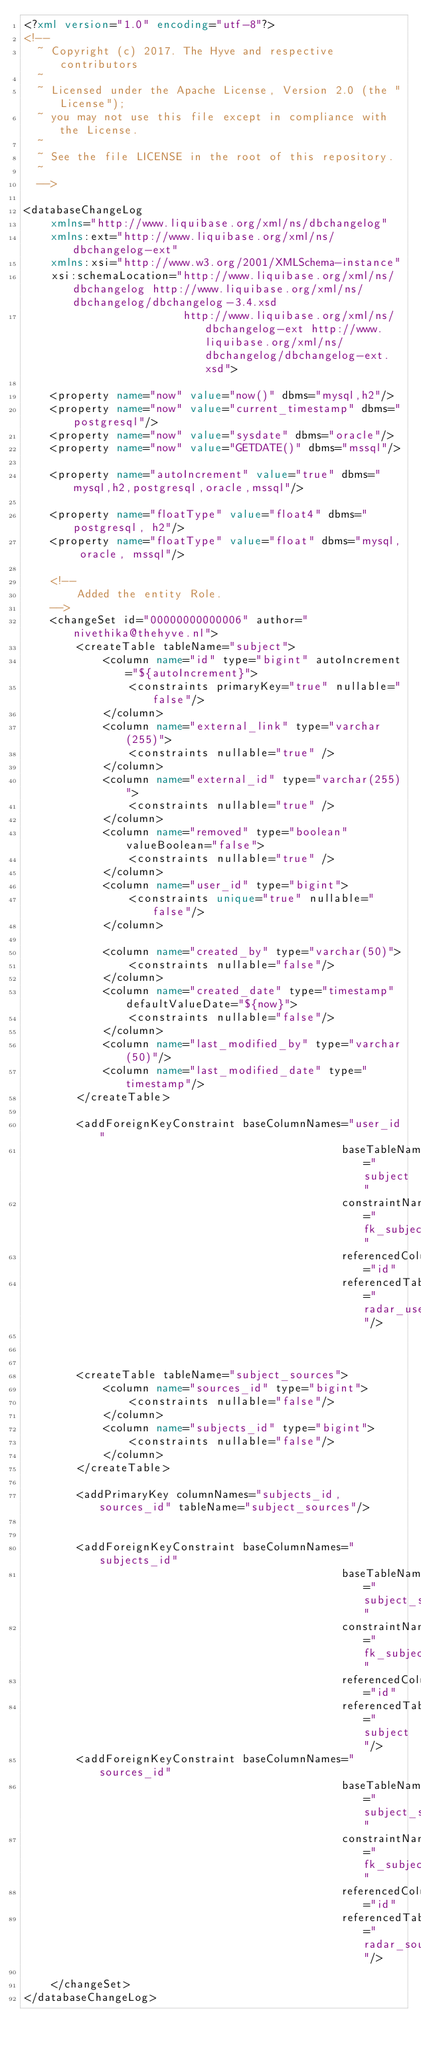Convert code to text. <code><loc_0><loc_0><loc_500><loc_500><_XML_><?xml version="1.0" encoding="utf-8"?>
<!--
  ~ Copyright (c) 2017. The Hyve and respective contributors
  ~
  ~ Licensed under the Apache License, Version 2.0 (the "License");
  ~ you may not use this file except in compliance with the License.
  ~
  ~ See the file LICENSE in the root of this repository.
  ~
  -->

<databaseChangeLog
    xmlns="http://www.liquibase.org/xml/ns/dbchangelog"
    xmlns:ext="http://www.liquibase.org/xml/ns/dbchangelog-ext"
    xmlns:xsi="http://www.w3.org/2001/XMLSchema-instance"
    xsi:schemaLocation="http://www.liquibase.org/xml/ns/dbchangelog http://www.liquibase.org/xml/ns/dbchangelog/dbchangelog-3.4.xsd
                        http://www.liquibase.org/xml/ns/dbchangelog-ext http://www.liquibase.org/xml/ns/dbchangelog/dbchangelog-ext.xsd">

    <property name="now" value="now()" dbms="mysql,h2"/>
    <property name="now" value="current_timestamp" dbms="postgresql"/>
    <property name="now" value="sysdate" dbms="oracle"/>
    <property name="now" value="GETDATE()" dbms="mssql"/>

    <property name="autoIncrement" value="true" dbms="mysql,h2,postgresql,oracle,mssql"/>

    <property name="floatType" value="float4" dbms="postgresql, h2"/>
    <property name="floatType" value="float" dbms="mysql, oracle, mssql"/>

    <!--
        Added the entity Role.
    -->
    <changeSet id="00000000000006" author="nivethika@thehyve.nl">
        <createTable tableName="subject">
            <column name="id" type="bigint" autoIncrement="${autoIncrement}">
                <constraints primaryKey="true" nullable="false"/>
            </column>
            <column name="external_link" type="varchar(255)">
                <constraints nullable="true" />
            </column>
            <column name="external_id" type="varchar(255)">
                <constraints nullable="true" />
            </column>
            <column name="removed" type="boolean" valueBoolean="false">
                <constraints nullable="true" />
            </column>
            <column name="user_id" type="bigint">
                <constraints unique="true" nullable="false"/>
            </column>

            <column name="created_by" type="varchar(50)">
                <constraints nullable="false"/>
            </column>
            <column name="created_date" type="timestamp" defaultValueDate="${now}">
                <constraints nullable="false"/>
            </column>
            <column name="last_modified_by" type="varchar(50)"/>
            <column name="last_modified_date" type="timestamp"/>
        </createTable>

        <addForeignKeyConstraint baseColumnNames="user_id"
                                                baseTableName="subject"
                                                constraintName="fk_subject_user_id"
                                                referencedColumnNames="id"
                                                referencedTableName="radar_user"/>



        <createTable tableName="subject_sources">
            <column name="sources_id" type="bigint">
                <constraints nullable="false"/>
            </column>
            <column name="subjects_id" type="bigint">
                <constraints nullable="false"/>
            </column>
        </createTable>

        <addPrimaryKey columnNames="subjects_id, sources_id" tableName="subject_sources"/>


        <addForeignKeyConstraint baseColumnNames="subjects_id"
                                                baseTableName="subject_sources"
                                                constraintName="fk_subject_sources_subjects_id"
                                                referencedColumnNames="id"
                                                referencedTableName="subject"/>
        <addForeignKeyConstraint baseColumnNames="sources_id"
                                                baseTableName="subject_sources"
                                                constraintName="fk_subject_sources_sources_id"
                                                referencedColumnNames="id"
                                                referencedTableName="radar_source"/>

    </changeSet>
</databaseChangeLog>
</code> 